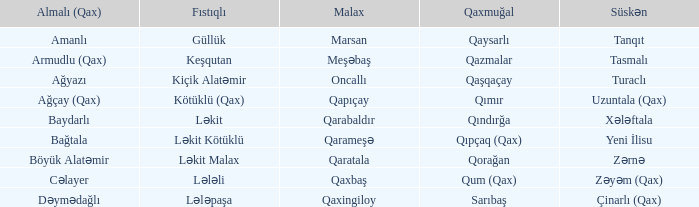I'm looking to parse the entire table for insights. Could you assist me with that? {'header': ['Almalı (Qax)', 'Fıstıqlı', 'Malax', 'Qaxmuğal', 'Süskən'], 'rows': [['Amanlı', 'Güllük', 'Marsan', 'Qaysarlı', 'Tanqıt'], ['Armudlu (Qax)', 'Keşqutan', 'Meşəbaş', 'Qazmalar', 'Tasmalı'], ['Ağyazı', 'Kiçik Alatəmir', 'Oncallı', 'Qaşqaçay', 'Turaclı'], ['Ağçay (Qax)', 'Kötüklü (Qax)', 'Qapıçay', 'Qımır', 'Uzuntala (Qax)'], ['Baydarlı', 'Ləkit', 'Qarabaldır', 'Qındırğa', 'Xələftala'], ['Bağtala', 'Ləkit Kötüklü', 'Qarameşə', 'Qıpçaq (Qax)', 'Yeni İlisu'], ['Böyük Alatəmir', 'Ləkit Malax', 'Qaratala', 'Qorağan', 'Zərnə'], ['Cəlayer', 'Lələli', 'Qaxbaş', 'Qum (Qax)', 'Zəyəm (Qax)'], ['Dəymədağlı', 'Lələpaşa', 'Qaxingiloy', 'Sarıbaş', 'Çinarlı (Qax)']]} What is the qaxmuğal village with a malax village forest leader? Qazmalar. 